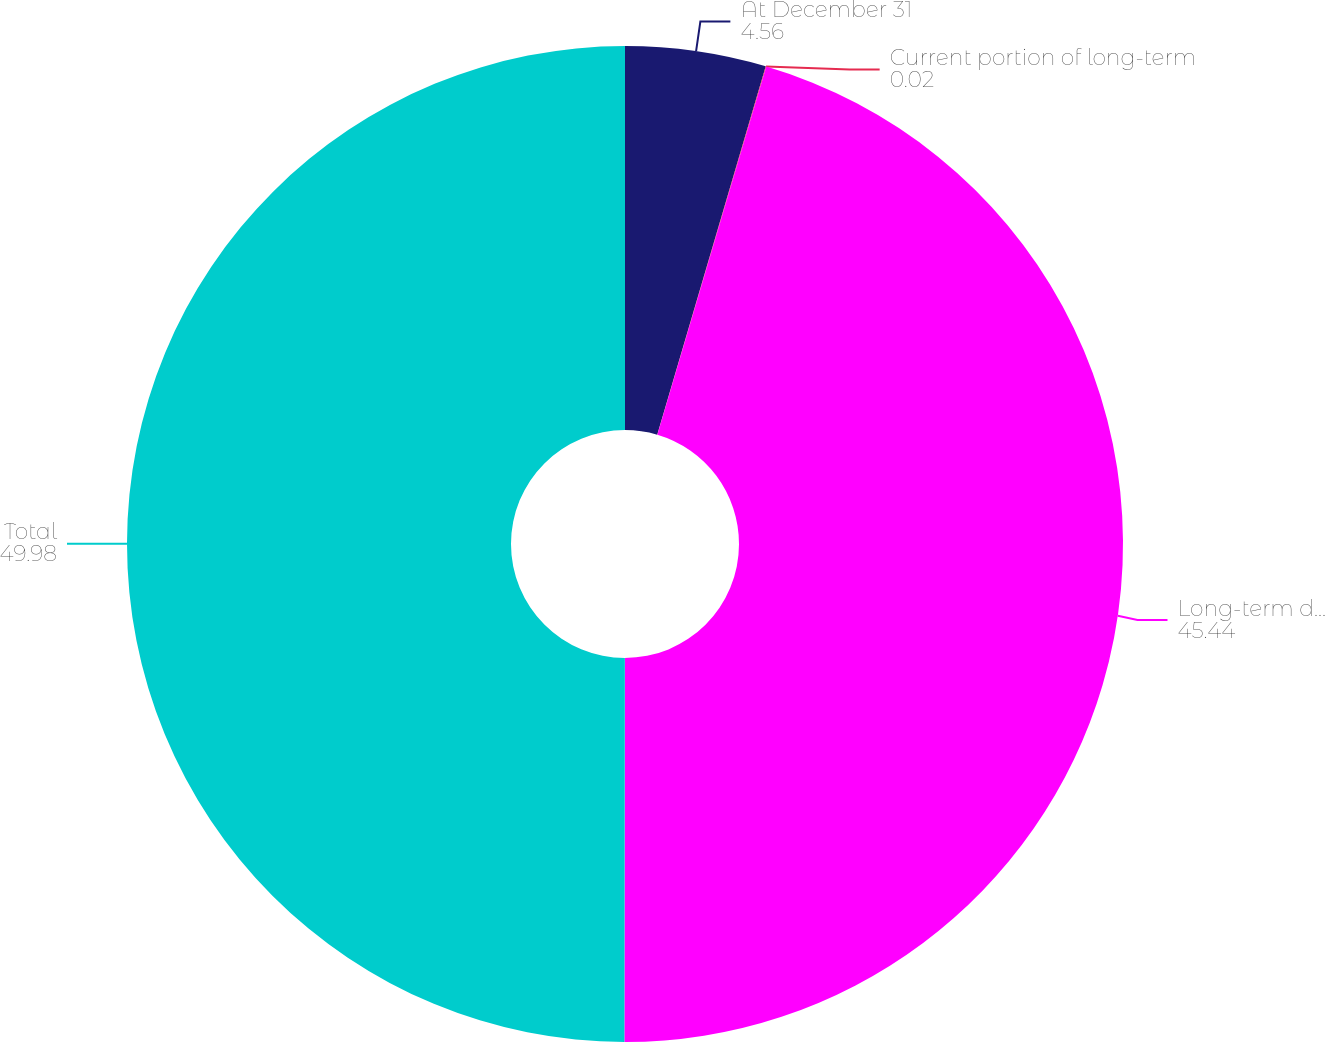<chart> <loc_0><loc_0><loc_500><loc_500><pie_chart><fcel>At December 31<fcel>Current portion of long-term<fcel>Long-term debt<fcel>Total<nl><fcel>4.56%<fcel>0.02%<fcel>45.44%<fcel>49.98%<nl></chart> 